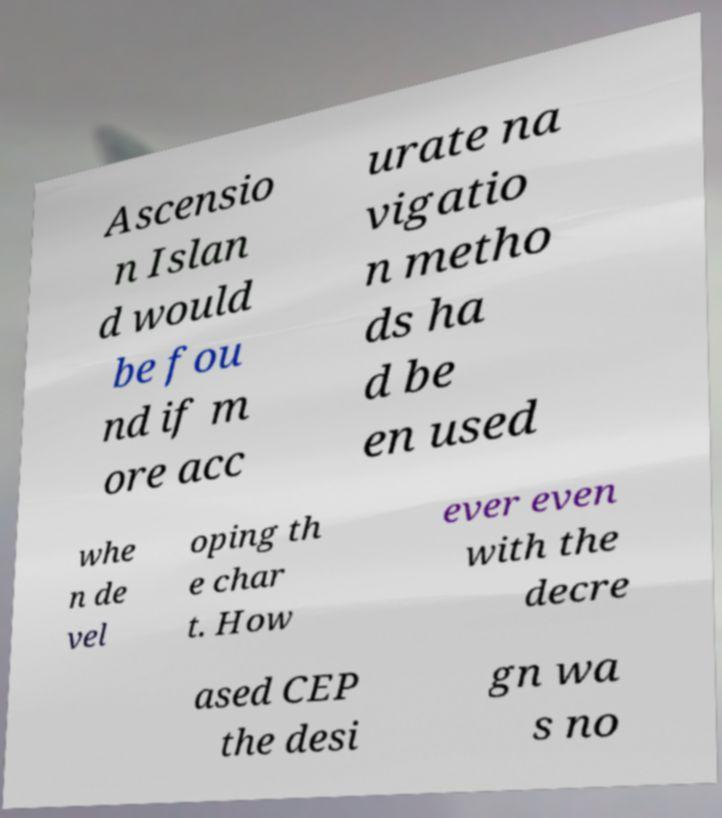I need the written content from this picture converted into text. Can you do that? Ascensio n Islan d would be fou nd if m ore acc urate na vigatio n metho ds ha d be en used whe n de vel oping th e char t. How ever even with the decre ased CEP the desi gn wa s no 